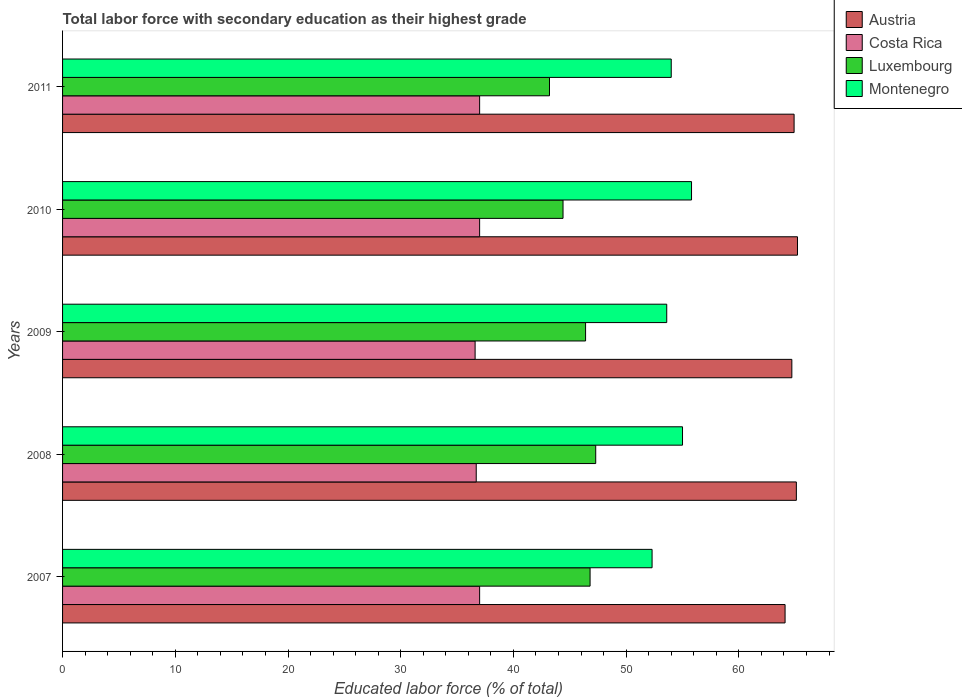How many different coloured bars are there?
Your answer should be very brief. 4. Are the number of bars on each tick of the Y-axis equal?
Keep it short and to the point. Yes. What is the percentage of total labor force with primary education in Montenegro in 2010?
Provide a succinct answer. 55.8. Across all years, what is the maximum percentage of total labor force with primary education in Luxembourg?
Keep it short and to the point. 47.3. Across all years, what is the minimum percentage of total labor force with primary education in Luxembourg?
Give a very brief answer. 43.2. What is the total percentage of total labor force with primary education in Austria in the graph?
Your answer should be very brief. 324. What is the difference between the percentage of total labor force with primary education in Luxembourg in 2007 and that in 2010?
Ensure brevity in your answer.  2.4. What is the difference between the percentage of total labor force with primary education in Montenegro in 2010 and the percentage of total labor force with primary education in Luxembourg in 2009?
Keep it short and to the point. 9.4. What is the average percentage of total labor force with primary education in Montenegro per year?
Offer a terse response. 54.14. In the year 2007, what is the difference between the percentage of total labor force with primary education in Luxembourg and percentage of total labor force with primary education in Austria?
Provide a succinct answer. -17.3. What is the ratio of the percentage of total labor force with primary education in Costa Rica in 2007 to that in 2009?
Ensure brevity in your answer.  1.01. Is the percentage of total labor force with primary education in Costa Rica in 2007 less than that in 2008?
Provide a short and direct response. No. Is the difference between the percentage of total labor force with primary education in Luxembourg in 2007 and 2010 greater than the difference between the percentage of total labor force with primary education in Austria in 2007 and 2010?
Provide a short and direct response. Yes. What is the difference between the highest and the second highest percentage of total labor force with primary education in Costa Rica?
Provide a short and direct response. 0. What is the difference between the highest and the lowest percentage of total labor force with primary education in Austria?
Provide a short and direct response. 1.1. Is the sum of the percentage of total labor force with primary education in Luxembourg in 2007 and 2010 greater than the maximum percentage of total labor force with primary education in Austria across all years?
Make the answer very short. Yes. Is it the case that in every year, the sum of the percentage of total labor force with primary education in Austria and percentage of total labor force with primary education in Luxembourg is greater than the sum of percentage of total labor force with primary education in Costa Rica and percentage of total labor force with primary education in Montenegro?
Your answer should be compact. No. What does the 4th bar from the bottom in 2007 represents?
Your answer should be very brief. Montenegro. Does the graph contain any zero values?
Offer a terse response. No. How are the legend labels stacked?
Provide a short and direct response. Vertical. What is the title of the graph?
Offer a very short reply. Total labor force with secondary education as their highest grade. Does "Virgin Islands" appear as one of the legend labels in the graph?
Offer a very short reply. No. What is the label or title of the X-axis?
Provide a succinct answer. Educated labor force (% of total). What is the Educated labor force (% of total) in Austria in 2007?
Provide a succinct answer. 64.1. What is the Educated labor force (% of total) in Luxembourg in 2007?
Your answer should be very brief. 46.8. What is the Educated labor force (% of total) of Montenegro in 2007?
Your answer should be very brief. 52.3. What is the Educated labor force (% of total) of Austria in 2008?
Offer a terse response. 65.1. What is the Educated labor force (% of total) in Costa Rica in 2008?
Your answer should be very brief. 36.7. What is the Educated labor force (% of total) of Luxembourg in 2008?
Give a very brief answer. 47.3. What is the Educated labor force (% of total) in Montenegro in 2008?
Your response must be concise. 55. What is the Educated labor force (% of total) in Austria in 2009?
Provide a succinct answer. 64.7. What is the Educated labor force (% of total) in Costa Rica in 2009?
Give a very brief answer. 36.6. What is the Educated labor force (% of total) of Luxembourg in 2009?
Make the answer very short. 46.4. What is the Educated labor force (% of total) of Montenegro in 2009?
Provide a succinct answer. 53.6. What is the Educated labor force (% of total) in Austria in 2010?
Make the answer very short. 65.2. What is the Educated labor force (% of total) of Luxembourg in 2010?
Your answer should be compact. 44.4. What is the Educated labor force (% of total) of Montenegro in 2010?
Offer a terse response. 55.8. What is the Educated labor force (% of total) of Austria in 2011?
Your response must be concise. 64.9. What is the Educated labor force (% of total) of Luxembourg in 2011?
Offer a very short reply. 43.2. What is the Educated labor force (% of total) in Montenegro in 2011?
Provide a short and direct response. 54. Across all years, what is the maximum Educated labor force (% of total) of Austria?
Your answer should be compact. 65.2. Across all years, what is the maximum Educated labor force (% of total) in Costa Rica?
Your response must be concise. 37. Across all years, what is the maximum Educated labor force (% of total) of Luxembourg?
Your answer should be very brief. 47.3. Across all years, what is the maximum Educated labor force (% of total) in Montenegro?
Provide a succinct answer. 55.8. Across all years, what is the minimum Educated labor force (% of total) in Austria?
Provide a succinct answer. 64.1. Across all years, what is the minimum Educated labor force (% of total) in Costa Rica?
Your response must be concise. 36.6. Across all years, what is the minimum Educated labor force (% of total) of Luxembourg?
Offer a terse response. 43.2. Across all years, what is the minimum Educated labor force (% of total) in Montenegro?
Offer a terse response. 52.3. What is the total Educated labor force (% of total) of Austria in the graph?
Your answer should be very brief. 324. What is the total Educated labor force (% of total) of Costa Rica in the graph?
Make the answer very short. 184.3. What is the total Educated labor force (% of total) in Luxembourg in the graph?
Provide a succinct answer. 228.1. What is the total Educated labor force (% of total) in Montenegro in the graph?
Make the answer very short. 270.7. What is the difference between the Educated labor force (% of total) of Austria in 2007 and that in 2008?
Make the answer very short. -1. What is the difference between the Educated labor force (% of total) of Luxembourg in 2007 and that in 2008?
Give a very brief answer. -0.5. What is the difference between the Educated labor force (% of total) of Austria in 2007 and that in 2009?
Make the answer very short. -0.6. What is the difference between the Educated labor force (% of total) of Costa Rica in 2007 and that in 2009?
Offer a very short reply. 0.4. What is the difference between the Educated labor force (% of total) in Luxembourg in 2007 and that in 2009?
Keep it short and to the point. 0.4. What is the difference between the Educated labor force (% of total) of Austria in 2007 and that in 2010?
Offer a terse response. -1.1. What is the difference between the Educated labor force (% of total) of Montenegro in 2007 and that in 2010?
Offer a very short reply. -3.5. What is the difference between the Educated labor force (% of total) in Austria in 2007 and that in 2011?
Offer a terse response. -0.8. What is the difference between the Educated labor force (% of total) in Montenegro in 2007 and that in 2011?
Provide a succinct answer. -1.7. What is the difference between the Educated labor force (% of total) of Austria in 2008 and that in 2009?
Ensure brevity in your answer.  0.4. What is the difference between the Educated labor force (% of total) in Costa Rica in 2008 and that in 2009?
Make the answer very short. 0.1. What is the difference between the Educated labor force (% of total) of Luxembourg in 2008 and that in 2009?
Your response must be concise. 0.9. What is the difference between the Educated labor force (% of total) in Montenegro in 2008 and that in 2009?
Make the answer very short. 1.4. What is the difference between the Educated labor force (% of total) in Costa Rica in 2008 and that in 2011?
Provide a short and direct response. -0.3. What is the difference between the Educated labor force (% of total) in Luxembourg in 2008 and that in 2011?
Offer a very short reply. 4.1. What is the difference between the Educated labor force (% of total) of Austria in 2009 and that in 2010?
Ensure brevity in your answer.  -0.5. What is the difference between the Educated labor force (% of total) of Luxembourg in 2009 and that in 2010?
Ensure brevity in your answer.  2. What is the difference between the Educated labor force (% of total) in Montenegro in 2009 and that in 2010?
Keep it short and to the point. -2.2. What is the difference between the Educated labor force (% of total) in Austria in 2009 and that in 2011?
Provide a succinct answer. -0.2. What is the difference between the Educated labor force (% of total) of Luxembourg in 2009 and that in 2011?
Provide a short and direct response. 3.2. What is the difference between the Educated labor force (% of total) in Montenegro in 2009 and that in 2011?
Offer a terse response. -0.4. What is the difference between the Educated labor force (% of total) in Austria in 2010 and that in 2011?
Make the answer very short. 0.3. What is the difference between the Educated labor force (% of total) of Costa Rica in 2010 and that in 2011?
Provide a short and direct response. 0. What is the difference between the Educated labor force (% of total) of Luxembourg in 2010 and that in 2011?
Your answer should be very brief. 1.2. What is the difference between the Educated labor force (% of total) of Montenegro in 2010 and that in 2011?
Ensure brevity in your answer.  1.8. What is the difference between the Educated labor force (% of total) in Austria in 2007 and the Educated labor force (% of total) in Costa Rica in 2008?
Provide a short and direct response. 27.4. What is the difference between the Educated labor force (% of total) in Austria in 2007 and the Educated labor force (% of total) in Montenegro in 2008?
Make the answer very short. 9.1. What is the difference between the Educated labor force (% of total) in Costa Rica in 2007 and the Educated labor force (% of total) in Luxembourg in 2008?
Keep it short and to the point. -10.3. What is the difference between the Educated labor force (% of total) of Luxembourg in 2007 and the Educated labor force (% of total) of Montenegro in 2008?
Your response must be concise. -8.2. What is the difference between the Educated labor force (% of total) of Austria in 2007 and the Educated labor force (% of total) of Luxembourg in 2009?
Offer a very short reply. 17.7. What is the difference between the Educated labor force (% of total) of Costa Rica in 2007 and the Educated labor force (% of total) of Luxembourg in 2009?
Your response must be concise. -9.4. What is the difference between the Educated labor force (% of total) of Costa Rica in 2007 and the Educated labor force (% of total) of Montenegro in 2009?
Provide a short and direct response. -16.6. What is the difference between the Educated labor force (% of total) in Luxembourg in 2007 and the Educated labor force (% of total) in Montenegro in 2009?
Give a very brief answer. -6.8. What is the difference between the Educated labor force (% of total) of Austria in 2007 and the Educated labor force (% of total) of Costa Rica in 2010?
Give a very brief answer. 27.1. What is the difference between the Educated labor force (% of total) of Austria in 2007 and the Educated labor force (% of total) of Montenegro in 2010?
Provide a short and direct response. 8.3. What is the difference between the Educated labor force (% of total) of Costa Rica in 2007 and the Educated labor force (% of total) of Luxembourg in 2010?
Provide a short and direct response. -7.4. What is the difference between the Educated labor force (% of total) in Costa Rica in 2007 and the Educated labor force (% of total) in Montenegro in 2010?
Provide a succinct answer. -18.8. What is the difference between the Educated labor force (% of total) in Austria in 2007 and the Educated labor force (% of total) in Costa Rica in 2011?
Offer a very short reply. 27.1. What is the difference between the Educated labor force (% of total) in Austria in 2007 and the Educated labor force (% of total) in Luxembourg in 2011?
Give a very brief answer. 20.9. What is the difference between the Educated labor force (% of total) of Austria in 2007 and the Educated labor force (% of total) of Montenegro in 2011?
Your answer should be compact. 10.1. What is the difference between the Educated labor force (% of total) in Costa Rica in 2007 and the Educated labor force (% of total) in Luxembourg in 2011?
Keep it short and to the point. -6.2. What is the difference between the Educated labor force (% of total) of Luxembourg in 2007 and the Educated labor force (% of total) of Montenegro in 2011?
Ensure brevity in your answer.  -7.2. What is the difference between the Educated labor force (% of total) of Austria in 2008 and the Educated labor force (% of total) of Montenegro in 2009?
Provide a short and direct response. 11.5. What is the difference between the Educated labor force (% of total) of Costa Rica in 2008 and the Educated labor force (% of total) of Montenegro in 2009?
Your answer should be very brief. -16.9. What is the difference between the Educated labor force (% of total) in Austria in 2008 and the Educated labor force (% of total) in Costa Rica in 2010?
Offer a terse response. 28.1. What is the difference between the Educated labor force (% of total) in Austria in 2008 and the Educated labor force (% of total) in Luxembourg in 2010?
Your answer should be very brief. 20.7. What is the difference between the Educated labor force (% of total) of Austria in 2008 and the Educated labor force (% of total) of Montenegro in 2010?
Your response must be concise. 9.3. What is the difference between the Educated labor force (% of total) in Costa Rica in 2008 and the Educated labor force (% of total) in Montenegro in 2010?
Offer a very short reply. -19.1. What is the difference between the Educated labor force (% of total) in Luxembourg in 2008 and the Educated labor force (% of total) in Montenegro in 2010?
Offer a very short reply. -8.5. What is the difference between the Educated labor force (% of total) in Austria in 2008 and the Educated labor force (% of total) in Costa Rica in 2011?
Provide a short and direct response. 28.1. What is the difference between the Educated labor force (% of total) of Austria in 2008 and the Educated labor force (% of total) of Luxembourg in 2011?
Provide a succinct answer. 21.9. What is the difference between the Educated labor force (% of total) of Austria in 2008 and the Educated labor force (% of total) of Montenegro in 2011?
Offer a terse response. 11.1. What is the difference between the Educated labor force (% of total) in Costa Rica in 2008 and the Educated labor force (% of total) in Luxembourg in 2011?
Your answer should be compact. -6.5. What is the difference between the Educated labor force (% of total) in Costa Rica in 2008 and the Educated labor force (% of total) in Montenegro in 2011?
Make the answer very short. -17.3. What is the difference between the Educated labor force (% of total) in Austria in 2009 and the Educated labor force (% of total) in Costa Rica in 2010?
Keep it short and to the point. 27.7. What is the difference between the Educated labor force (% of total) in Austria in 2009 and the Educated labor force (% of total) in Luxembourg in 2010?
Ensure brevity in your answer.  20.3. What is the difference between the Educated labor force (% of total) in Costa Rica in 2009 and the Educated labor force (% of total) in Luxembourg in 2010?
Your answer should be compact. -7.8. What is the difference between the Educated labor force (% of total) in Costa Rica in 2009 and the Educated labor force (% of total) in Montenegro in 2010?
Offer a terse response. -19.2. What is the difference between the Educated labor force (% of total) of Austria in 2009 and the Educated labor force (% of total) of Costa Rica in 2011?
Provide a short and direct response. 27.7. What is the difference between the Educated labor force (% of total) in Costa Rica in 2009 and the Educated labor force (% of total) in Montenegro in 2011?
Your response must be concise. -17.4. What is the difference between the Educated labor force (% of total) of Austria in 2010 and the Educated labor force (% of total) of Costa Rica in 2011?
Make the answer very short. 28.2. What is the average Educated labor force (% of total) in Austria per year?
Provide a succinct answer. 64.8. What is the average Educated labor force (% of total) of Costa Rica per year?
Your answer should be very brief. 36.86. What is the average Educated labor force (% of total) in Luxembourg per year?
Your response must be concise. 45.62. What is the average Educated labor force (% of total) in Montenegro per year?
Make the answer very short. 54.14. In the year 2007, what is the difference between the Educated labor force (% of total) in Austria and Educated labor force (% of total) in Costa Rica?
Your answer should be compact. 27.1. In the year 2007, what is the difference between the Educated labor force (% of total) of Austria and Educated labor force (% of total) of Luxembourg?
Provide a short and direct response. 17.3. In the year 2007, what is the difference between the Educated labor force (% of total) in Costa Rica and Educated labor force (% of total) in Montenegro?
Keep it short and to the point. -15.3. In the year 2007, what is the difference between the Educated labor force (% of total) of Luxembourg and Educated labor force (% of total) of Montenegro?
Provide a short and direct response. -5.5. In the year 2008, what is the difference between the Educated labor force (% of total) in Austria and Educated labor force (% of total) in Costa Rica?
Keep it short and to the point. 28.4. In the year 2008, what is the difference between the Educated labor force (% of total) of Austria and Educated labor force (% of total) of Luxembourg?
Make the answer very short. 17.8. In the year 2008, what is the difference between the Educated labor force (% of total) of Costa Rica and Educated labor force (% of total) of Montenegro?
Provide a succinct answer. -18.3. In the year 2008, what is the difference between the Educated labor force (% of total) of Luxembourg and Educated labor force (% of total) of Montenegro?
Your response must be concise. -7.7. In the year 2009, what is the difference between the Educated labor force (% of total) of Austria and Educated labor force (% of total) of Costa Rica?
Your response must be concise. 28.1. In the year 2009, what is the difference between the Educated labor force (% of total) of Austria and Educated labor force (% of total) of Luxembourg?
Provide a succinct answer. 18.3. In the year 2009, what is the difference between the Educated labor force (% of total) in Austria and Educated labor force (% of total) in Montenegro?
Ensure brevity in your answer.  11.1. In the year 2009, what is the difference between the Educated labor force (% of total) in Costa Rica and Educated labor force (% of total) in Luxembourg?
Give a very brief answer. -9.8. In the year 2009, what is the difference between the Educated labor force (% of total) of Luxembourg and Educated labor force (% of total) of Montenegro?
Your answer should be very brief. -7.2. In the year 2010, what is the difference between the Educated labor force (% of total) in Austria and Educated labor force (% of total) in Costa Rica?
Offer a very short reply. 28.2. In the year 2010, what is the difference between the Educated labor force (% of total) in Austria and Educated labor force (% of total) in Luxembourg?
Make the answer very short. 20.8. In the year 2010, what is the difference between the Educated labor force (% of total) in Austria and Educated labor force (% of total) in Montenegro?
Ensure brevity in your answer.  9.4. In the year 2010, what is the difference between the Educated labor force (% of total) of Costa Rica and Educated labor force (% of total) of Luxembourg?
Your response must be concise. -7.4. In the year 2010, what is the difference between the Educated labor force (% of total) of Costa Rica and Educated labor force (% of total) of Montenegro?
Make the answer very short. -18.8. In the year 2010, what is the difference between the Educated labor force (% of total) in Luxembourg and Educated labor force (% of total) in Montenegro?
Provide a short and direct response. -11.4. In the year 2011, what is the difference between the Educated labor force (% of total) in Austria and Educated labor force (% of total) in Costa Rica?
Provide a succinct answer. 27.9. In the year 2011, what is the difference between the Educated labor force (% of total) in Austria and Educated labor force (% of total) in Luxembourg?
Your answer should be very brief. 21.7. In the year 2011, what is the difference between the Educated labor force (% of total) of Austria and Educated labor force (% of total) of Montenegro?
Give a very brief answer. 10.9. In the year 2011, what is the difference between the Educated labor force (% of total) of Costa Rica and Educated labor force (% of total) of Luxembourg?
Provide a short and direct response. -6.2. In the year 2011, what is the difference between the Educated labor force (% of total) of Luxembourg and Educated labor force (% of total) of Montenegro?
Provide a succinct answer. -10.8. What is the ratio of the Educated labor force (% of total) in Austria in 2007 to that in 2008?
Keep it short and to the point. 0.98. What is the ratio of the Educated labor force (% of total) in Costa Rica in 2007 to that in 2008?
Your answer should be very brief. 1.01. What is the ratio of the Educated labor force (% of total) of Montenegro in 2007 to that in 2008?
Your answer should be very brief. 0.95. What is the ratio of the Educated labor force (% of total) in Austria in 2007 to that in 2009?
Provide a succinct answer. 0.99. What is the ratio of the Educated labor force (% of total) in Costa Rica in 2007 to that in 2009?
Offer a very short reply. 1.01. What is the ratio of the Educated labor force (% of total) of Luxembourg in 2007 to that in 2009?
Your answer should be compact. 1.01. What is the ratio of the Educated labor force (% of total) of Montenegro in 2007 to that in 2009?
Offer a terse response. 0.98. What is the ratio of the Educated labor force (% of total) of Austria in 2007 to that in 2010?
Provide a short and direct response. 0.98. What is the ratio of the Educated labor force (% of total) in Costa Rica in 2007 to that in 2010?
Make the answer very short. 1. What is the ratio of the Educated labor force (% of total) in Luxembourg in 2007 to that in 2010?
Offer a terse response. 1.05. What is the ratio of the Educated labor force (% of total) in Montenegro in 2007 to that in 2010?
Your answer should be compact. 0.94. What is the ratio of the Educated labor force (% of total) in Montenegro in 2007 to that in 2011?
Offer a very short reply. 0.97. What is the ratio of the Educated labor force (% of total) of Luxembourg in 2008 to that in 2009?
Your answer should be very brief. 1.02. What is the ratio of the Educated labor force (% of total) in Montenegro in 2008 to that in 2009?
Provide a short and direct response. 1.03. What is the ratio of the Educated labor force (% of total) of Austria in 2008 to that in 2010?
Make the answer very short. 1. What is the ratio of the Educated labor force (% of total) of Luxembourg in 2008 to that in 2010?
Your answer should be compact. 1.07. What is the ratio of the Educated labor force (% of total) of Montenegro in 2008 to that in 2010?
Keep it short and to the point. 0.99. What is the ratio of the Educated labor force (% of total) of Costa Rica in 2008 to that in 2011?
Your response must be concise. 0.99. What is the ratio of the Educated labor force (% of total) of Luxembourg in 2008 to that in 2011?
Give a very brief answer. 1.09. What is the ratio of the Educated labor force (% of total) in Montenegro in 2008 to that in 2011?
Provide a succinct answer. 1.02. What is the ratio of the Educated labor force (% of total) of Austria in 2009 to that in 2010?
Your answer should be very brief. 0.99. What is the ratio of the Educated labor force (% of total) in Costa Rica in 2009 to that in 2010?
Offer a terse response. 0.99. What is the ratio of the Educated labor force (% of total) of Luxembourg in 2009 to that in 2010?
Provide a short and direct response. 1.04. What is the ratio of the Educated labor force (% of total) of Montenegro in 2009 to that in 2010?
Keep it short and to the point. 0.96. What is the ratio of the Educated labor force (% of total) of Austria in 2009 to that in 2011?
Keep it short and to the point. 1. What is the ratio of the Educated labor force (% of total) of Costa Rica in 2009 to that in 2011?
Your answer should be compact. 0.99. What is the ratio of the Educated labor force (% of total) in Luxembourg in 2009 to that in 2011?
Ensure brevity in your answer.  1.07. What is the ratio of the Educated labor force (% of total) of Montenegro in 2009 to that in 2011?
Provide a short and direct response. 0.99. What is the ratio of the Educated labor force (% of total) of Luxembourg in 2010 to that in 2011?
Offer a very short reply. 1.03. What is the difference between the highest and the second highest Educated labor force (% of total) in Austria?
Your answer should be compact. 0.1. What is the difference between the highest and the lowest Educated labor force (% of total) of Costa Rica?
Give a very brief answer. 0.4. What is the difference between the highest and the lowest Educated labor force (% of total) in Luxembourg?
Your answer should be compact. 4.1. What is the difference between the highest and the lowest Educated labor force (% of total) of Montenegro?
Provide a short and direct response. 3.5. 